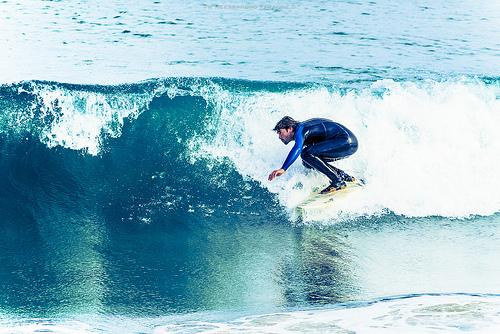What is the body position of the person surfing and what is their hair length? The person surfing is leaning over the board with bent knees and has collar-length dark hair. Can you count how many legs are detected in the image? Two legs were detected in the image. Evaluate the quality of the image by analyzing the elements detected in it. The image contains various elements like person, surfboard, and the ocean, providing a visually rich scene with high-quality detection. Describe the color and appearance of the water in the image. The water is a beautiful turquoise blue color, and the ocean wave has a white crest. What is the color of the person's wetsuit while surfing on the ocean wave? The person's wetsuit is dark blue. Describe any object interactions in the image. The person is balancing on a beige surfboard while surfing on an ocean wave, with their reflection mirrored in the water. Identify the activity involving the person that provides a challenge for maintaining balance. The person is trying to maintain balance while surfing on a wave in the ocean. Determine if there is any complex reasoning depicted within the image. The image displays complex reasoning as the person demonstrates the skill of surfing, maintaining balance and interacting with the ocean environment. How is the person using their left arm during the activity? The person has their left arm forward to help with balance while surfing. Do any sentiments or emotions come through from the image? If yes, provide a brief description. The image conveys a sense of excitement and adventure as the person surfs on the ocean wave. An interesting aspect of this image is the silhouette of a shark beneath the ocean surface, do you see it? The existing information does not mention a shark in the image, which makes this instruction misleading for the viewer. Can you spot the dolphin swimming beside the surfer? No, it's not mentioned in the image. What color is the surfer's yellow helmet on their head? The provided information does not mention the presence of a helmet on the surfer's head or any yellow color, thus making it misleading. 